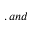<formula> <loc_0><loc_0><loc_500><loc_500>, a n d</formula> 